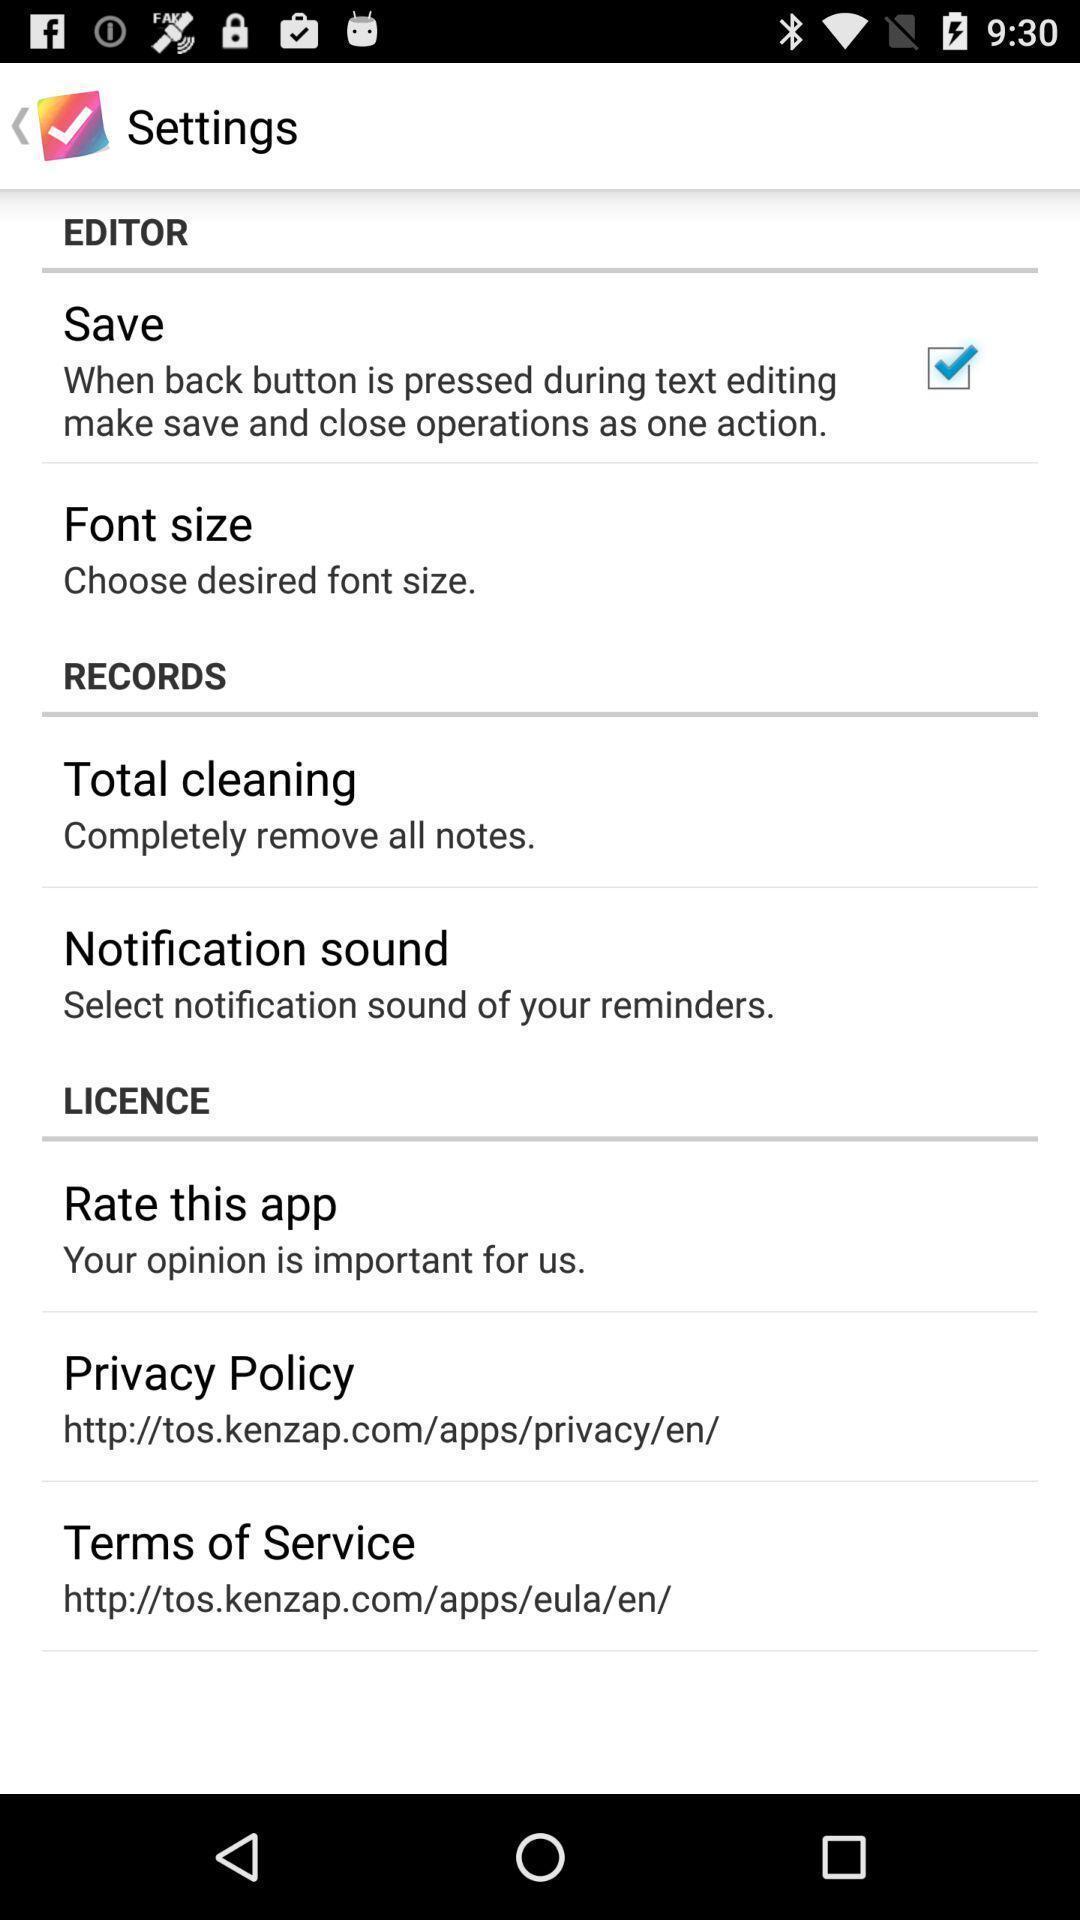Explain the elements present in this screenshot. Settings page with different options in the text editing app. 